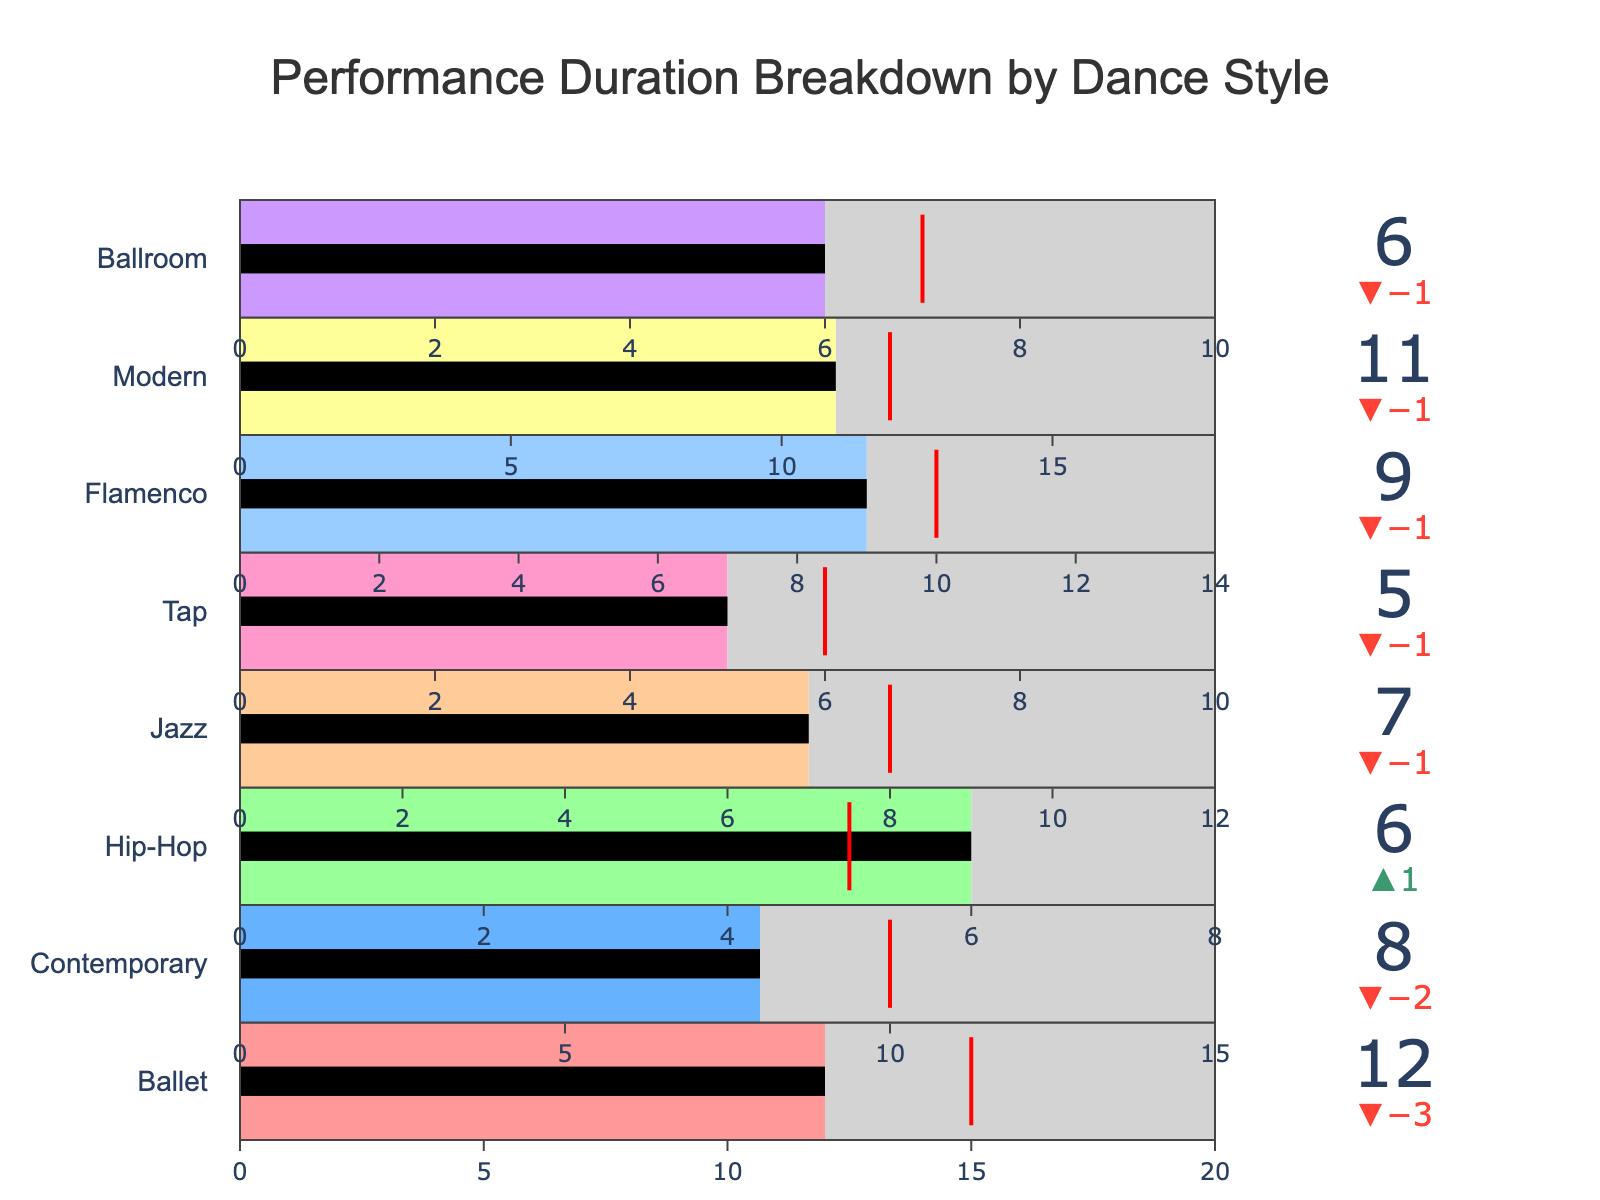How many dance styles are represented in the chart? Count the unique dance styles listed in the bullet chart.
Answer: 8 Which dance style has the highest actual duration? Compare the actual duration values of all dance styles and identify the highest one. Ballet has 12, Contemporary has 8, Hip-Hop has 6, Jazz has 7, Tap has 5, Flamenco has 9, Modern has 11, Ballroom has 6. Ballet has the highest duration which is 12.
Answer: Ballet What is the difference between the actual and target duration for Contemporary? Subtract the target duration from the actual duration for the Contemporary dance style. Actual duration is 8, target duration is 10, so the difference is 8 - 10 = -2.
Answer: -2 Which dance style surpasses its target duration? Examine each dance style's actual duration and see if it exceeds its target duration. Hip-Hop has actual duration 6 and target duration 5, so it surpasses its target.
Answer: Hip-Hop Which dance style has the smallest margin between its maximum and target duration? Calculate the difference between the maximum and target duration for each dance style and find the smallest one. Ballet: 20-15=5, Contemporary: 15-10=5, Hip-Hop: 8-5=3, Jazz: 12-8=4, Tap: 10-6=4, Flamenco: 14-10=4, Modern: 18-12=6, Ballroom: 10-7=3. Hip-Hop and Ballroom have the smallest margin.
Answer: Hip-Hop, Ballroom What is the total actual duration of all dance styles? Sum up the actual duration values of all dance styles. 12 (Ballet) + 8 (Contemporary) + 6 (Hip-Hop) + 7 (Jazz) + 5 (Tap) + 9 (Flamenco) + 11 (Modern) + 6 (Ballroom) = 64.
Answer: 64 How does the actual duration of Jazz compare to its maximum duration? Compare the actual duration of Jazz (7) to its maximum duration (12).
Answer: Less than What's the average target duration across all dance styles? Sum the target durations and divide by the number of dance styles. (15 + 10 + 5 + 8 + 6 + 10 + 12 + 7)/8 = 73/8 = 9.125
Answer: 9.125 Which dance styles have actual durations falling short of their target durations by more than 1 unit? Identify dance styles with an actual duration at least 1 unit less than their target duration. Ballet: 12-15=-3, Contemporary: 8-10=-2, Tap: 5-6=-1, Flamenco: 9-10=-1, Modern: 11-12=-1.
Answer: Ballet, Contemporary For which dance style is the bar color black? Check which dance style's actual duration bar is in black color indicating exceeding or equal to target. All dance styles that exceed or are equal to their target have a black bar.
Answer: Hip-Hop 